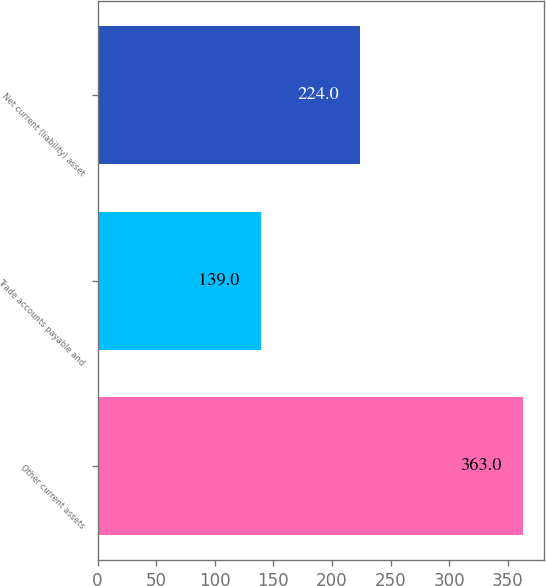Convert chart. <chart><loc_0><loc_0><loc_500><loc_500><bar_chart><fcel>Other current assets<fcel>Trade accounts payable and<fcel>Net current (liability) asset<nl><fcel>363<fcel>139<fcel>224<nl></chart> 